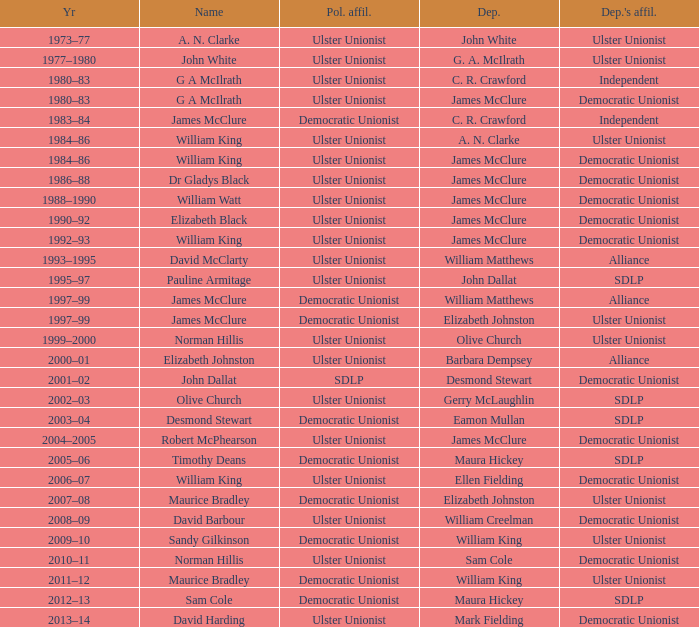Give me the full table as a dictionary. {'header': ['Yr', 'Name', 'Pol. affil.', 'Dep.', "Dep.'s affil."], 'rows': [['1973–77', 'A. N. Clarke', 'Ulster Unionist', 'John White', 'Ulster Unionist'], ['1977–1980', 'John White', 'Ulster Unionist', 'G. A. McIlrath', 'Ulster Unionist'], ['1980–83', 'G A McIlrath', 'Ulster Unionist', 'C. R. Crawford', 'Independent'], ['1980–83', 'G A McIlrath', 'Ulster Unionist', 'James McClure', 'Democratic Unionist'], ['1983–84', 'James McClure', 'Democratic Unionist', 'C. R. Crawford', 'Independent'], ['1984–86', 'William King', 'Ulster Unionist', 'A. N. Clarke', 'Ulster Unionist'], ['1984–86', 'William King', 'Ulster Unionist', 'James McClure', 'Democratic Unionist'], ['1986–88', 'Dr Gladys Black', 'Ulster Unionist', 'James McClure', 'Democratic Unionist'], ['1988–1990', 'William Watt', 'Ulster Unionist', 'James McClure', 'Democratic Unionist'], ['1990–92', 'Elizabeth Black', 'Ulster Unionist', 'James McClure', 'Democratic Unionist'], ['1992–93', 'William King', 'Ulster Unionist', 'James McClure', 'Democratic Unionist'], ['1993–1995', 'David McClarty', 'Ulster Unionist', 'William Matthews', 'Alliance'], ['1995–97', 'Pauline Armitage', 'Ulster Unionist', 'John Dallat', 'SDLP'], ['1997–99', 'James McClure', 'Democratic Unionist', 'William Matthews', 'Alliance'], ['1997–99', 'James McClure', 'Democratic Unionist', 'Elizabeth Johnston', 'Ulster Unionist'], ['1999–2000', 'Norman Hillis', 'Ulster Unionist', 'Olive Church', 'Ulster Unionist'], ['2000–01', 'Elizabeth Johnston', 'Ulster Unionist', 'Barbara Dempsey', 'Alliance'], ['2001–02', 'John Dallat', 'SDLP', 'Desmond Stewart', 'Democratic Unionist'], ['2002–03', 'Olive Church', 'Ulster Unionist', 'Gerry McLaughlin', 'SDLP'], ['2003–04', 'Desmond Stewart', 'Democratic Unionist', 'Eamon Mullan', 'SDLP'], ['2004–2005', 'Robert McPhearson', 'Ulster Unionist', 'James McClure', 'Democratic Unionist'], ['2005–06', 'Timothy Deans', 'Democratic Unionist', 'Maura Hickey', 'SDLP'], ['2006–07', 'William King', 'Ulster Unionist', 'Ellen Fielding', 'Democratic Unionist'], ['2007–08', 'Maurice Bradley', 'Democratic Unionist', 'Elizabeth Johnston', 'Ulster Unionist'], ['2008–09', 'David Barbour', 'Ulster Unionist', 'William Creelman', 'Democratic Unionist'], ['2009–10', 'Sandy Gilkinson', 'Democratic Unionist', 'William King', 'Ulster Unionist'], ['2010–11', 'Norman Hillis', 'Ulster Unionist', 'Sam Cole', 'Democratic Unionist'], ['2011–12', 'Maurice Bradley', 'Democratic Unionist', 'William King', 'Ulster Unionist'], ['2012–13', 'Sam Cole', 'Democratic Unionist', 'Maura Hickey', 'SDLP'], ['2013–14', 'David Harding', 'Ulster Unionist', 'Mark Fielding', 'Democratic Unionist']]} What is the Political affiliation of deputy john dallat? Ulster Unionist. 